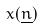<formula> <loc_0><loc_0><loc_500><loc_500>x ( \underline { n } )</formula> 